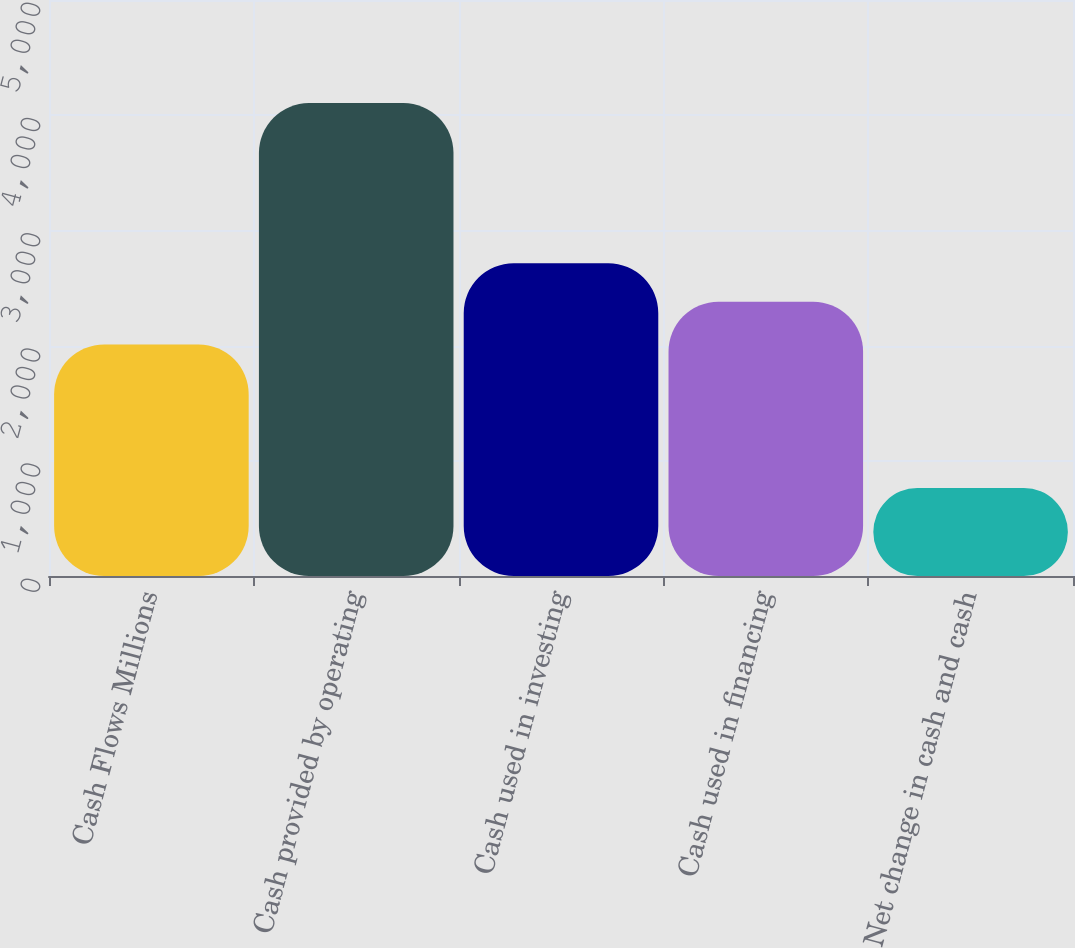Convert chart. <chart><loc_0><loc_0><loc_500><loc_500><bar_chart><fcel>Cash Flows Millions<fcel>Cash provided by operating<fcel>Cash used in investing<fcel>Cash used in financing<fcel>Net change in cash and cash<nl><fcel>2010<fcel>4105<fcel>2715.1<fcel>2381<fcel>764<nl></chart> 